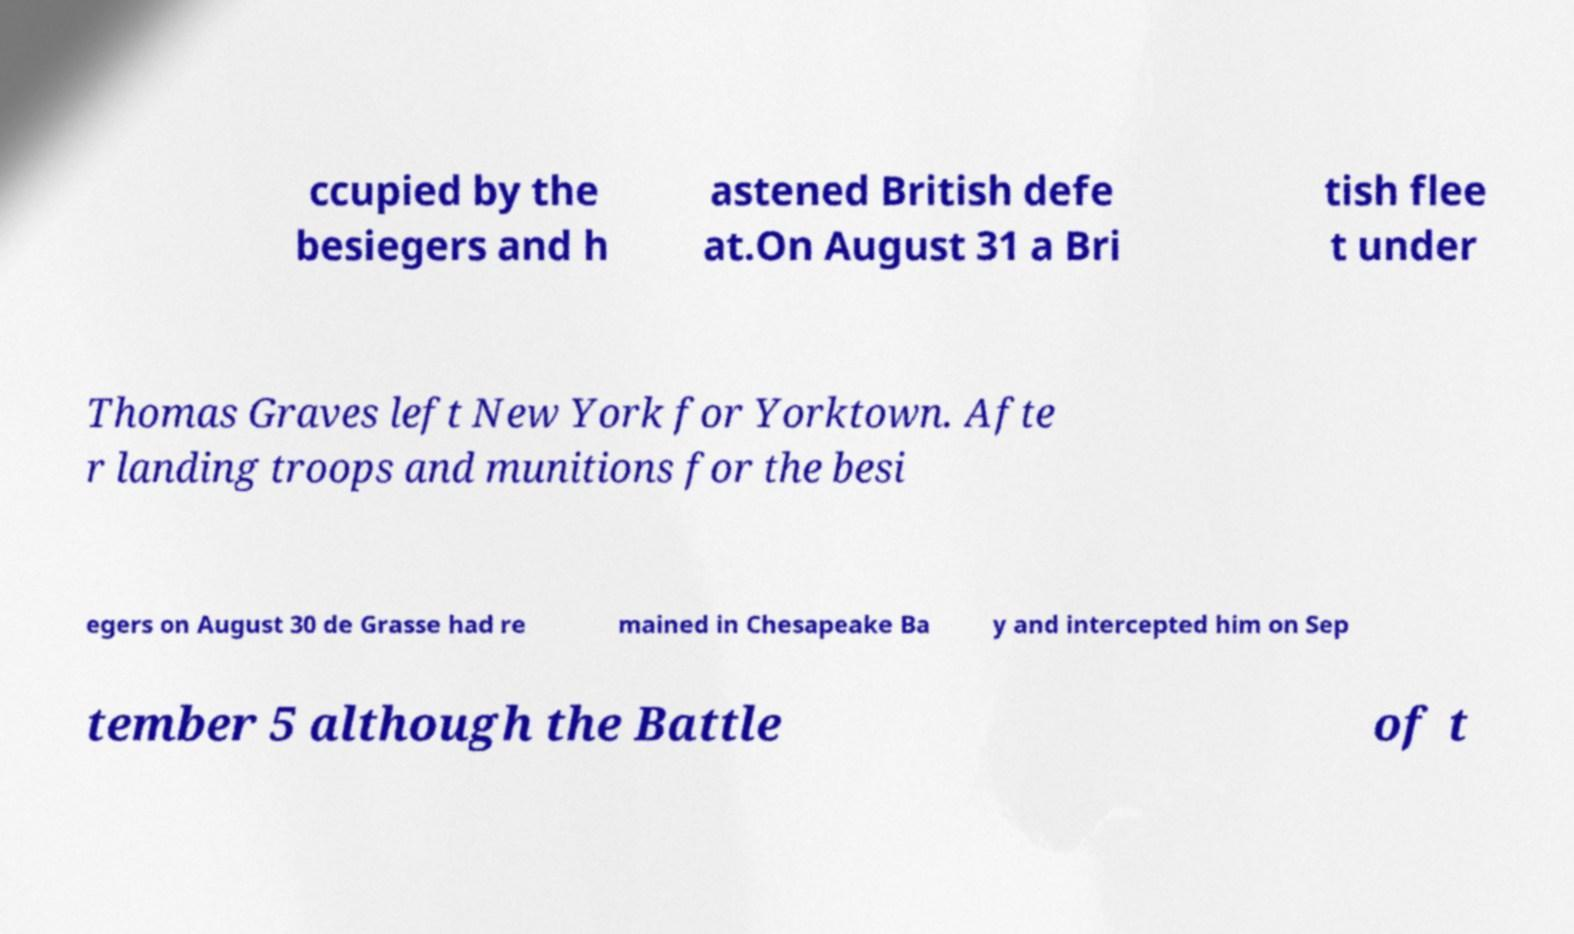Please identify and transcribe the text found in this image. ccupied by the besiegers and h astened British defe at.On August 31 a Bri tish flee t under Thomas Graves left New York for Yorktown. Afte r landing troops and munitions for the besi egers on August 30 de Grasse had re mained in Chesapeake Ba y and intercepted him on Sep tember 5 although the Battle of t 